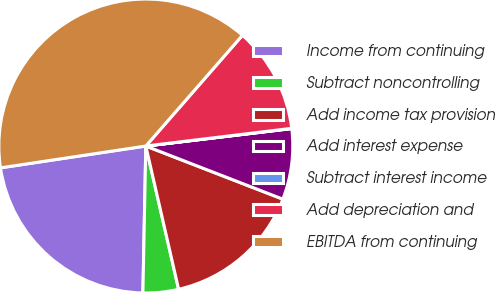Convert chart. <chart><loc_0><loc_0><loc_500><loc_500><pie_chart><fcel>Income from continuing<fcel>Subtract noncontrolling<fcel>Add income tax provision<fcel>Add interest expense<fcel>Subtract interest income<fcel>Add depreciation and<fcel>EBITDA from continuing<nl><fcel>22.31%<fcel>3.9%<fcel>15.53%<fcel>7.78%<fcel>0.03%<fcel>11.66%<fcel>38.79%<nl></chart> 